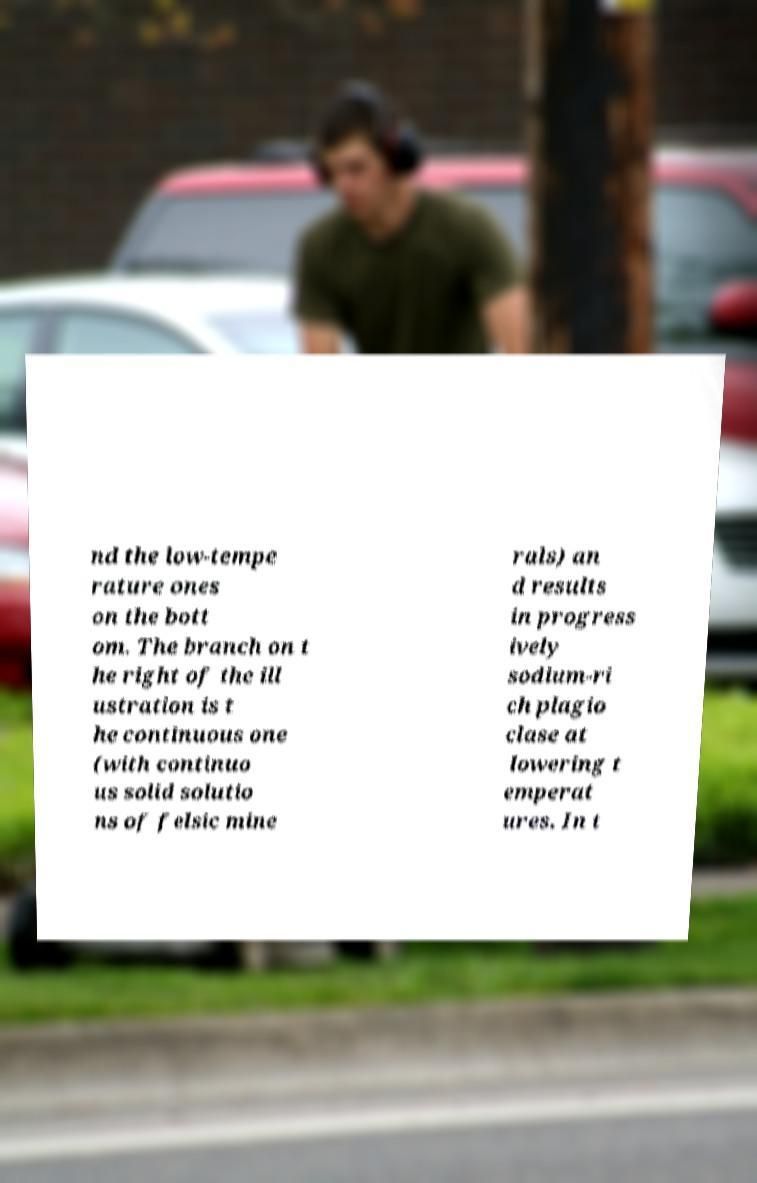Could you extract and type out the text from this image? nd the low-tempe rature ones on the bott om. The branch on t he right of the ill ustration is t he continuous one (with continuo us solid solutio ns of felsic mine rals) an d results in progress ively sodium-ri ch plagio clase at lowering t emperat ures. In t 